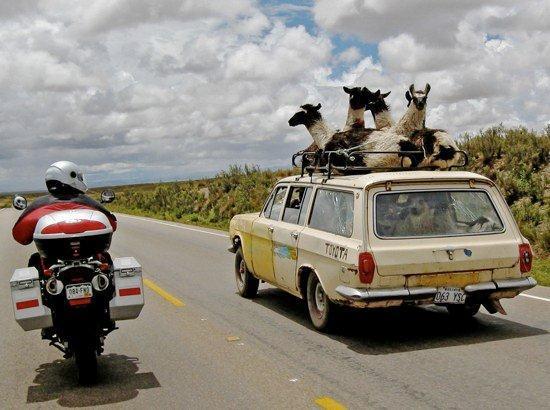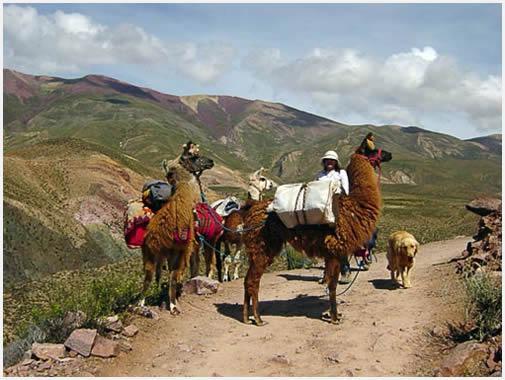The first image is the image on the left, the second image is the image on the right. Given the left and right images, does the statement "In at least one one image there is a single lama facing right with some white fur and a rope around its neck." hold true? Answer yes or no. No. The first image is the image on the left, the second image is the image on the right. For the images shown, is this caption "In one of the images, the animals are close to an automobile." true? Answer yes or no. Yes. 